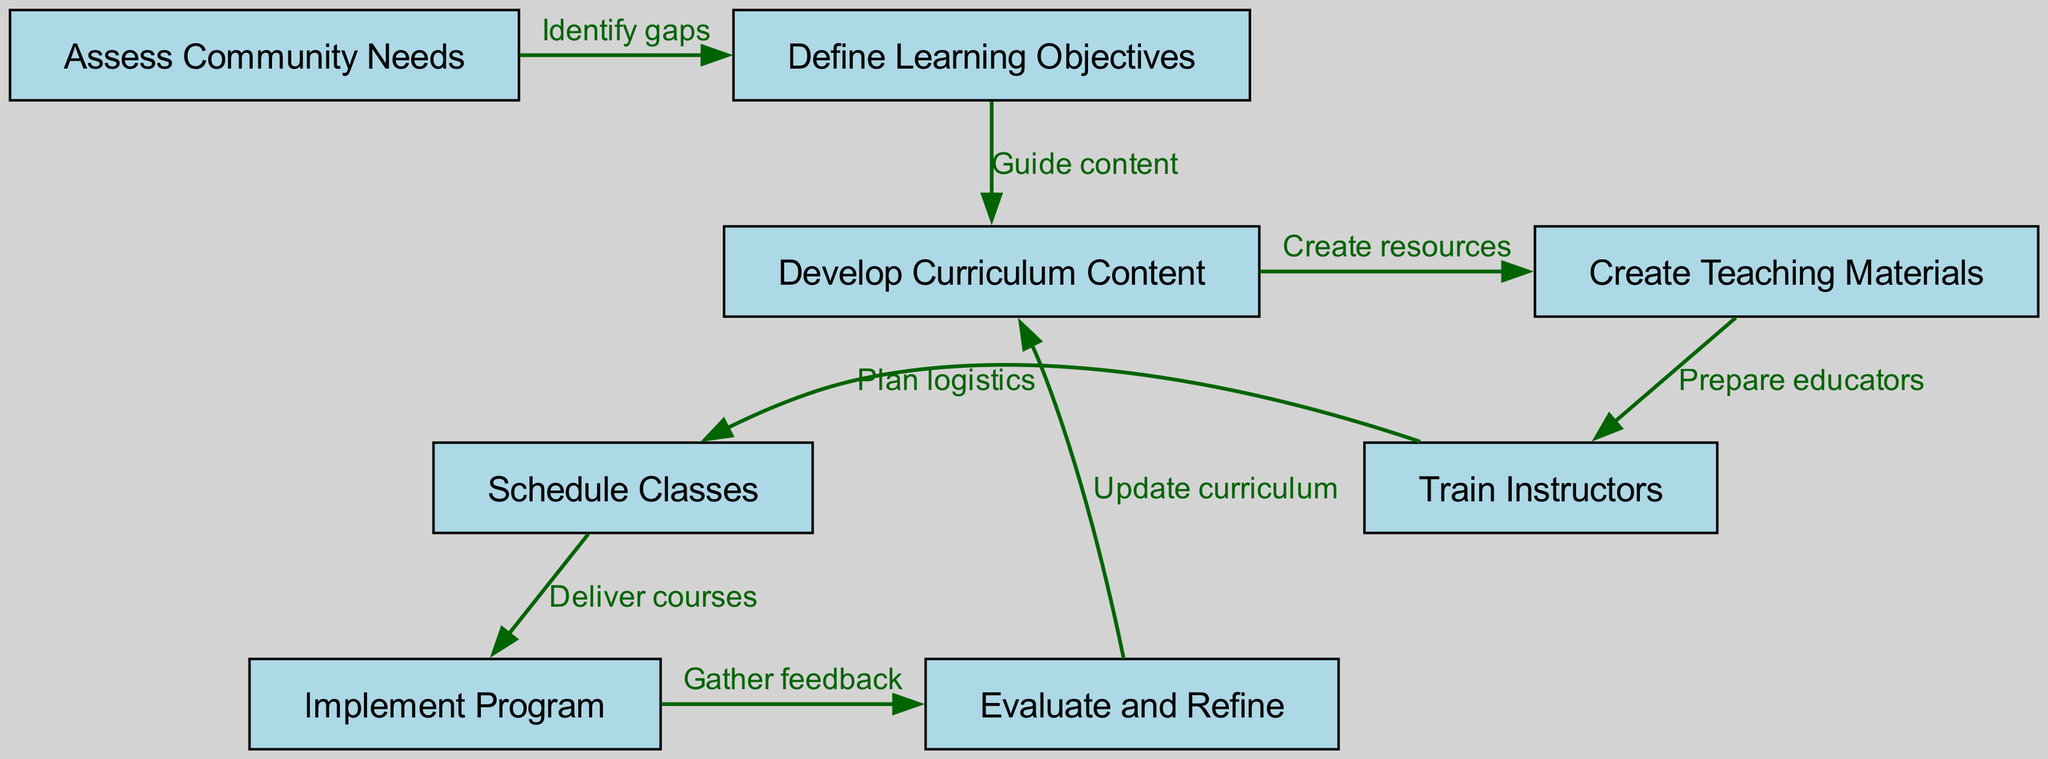What is the first step in the process? The first node in the diagram is labeled "Assess Community Needs", indicating that it is the initial step that needs to be taken.
Answer: Assess Community Needs How many nodes are present in the diagram? By counting the nodes in the provided data, there are eight distinct nodes representing different stages in the financial literacy curriculum process.
Answer: Eight What is the relationship between "Evaluate and Refine" and "Develop Curriculum Content"? The "Evaluate and Refine" node has a directed edge back to "Develop Curriculum Content" indicating the process indicates that feedback from evaluation leads to updating or refining curriculum content.
Answer: Update curriculum How many edges are there in total? The data shows eight edges connecting the different nodes, which represent various steps and their transitions in the curriculum development process.
Answer: Eight Which step is directly followed by "Train Instructors"? The "Train Instructors" node is directly preceded by the "Create Teaching Materials" node, so the process of creating materials occurs before training instructors.
Answer: Create Teaching Materials What is the purpose of the edge labeled "Deliver courses"? The edge labeled "Deliver courses" indicates the action of implementing the program, which comes after scheduling classes outlined in the previous node.
Answer: Implement Program Which node is connected to "Assess Community Needs" by an edge labeled "Identify gaps"? The edge labeled "Identify gaps" connects the "Assess Community Needs" node to the "Define Learning Objectives" node, showing that identifying gaps leads to determining specific learning objectives.
Answer: Define Learning Objectives What happens after "Implement Program"? After the implementation of the program, the next step is "Evaluate and Refine", which indicates that an evaluation process occurs following the program's implementation.
Answer: Evaluate and Refine Which two nodes are separated by the edge labeled "Prepare educators"? The edge labeled "Prepare educators" connects "Create Teaching Materials" to "Train Instructors", indicating that the preparation of teaching materials is a prerequisite step to preparing the educators who will teach the curriculum.
Answer: Train Instructors 